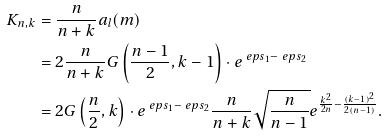<formula> <loc_0><loc_0><loc_500><loc_500>K _ { n , k } & = \frac { n } { n + k } a _ { l } ( m ) \\ & = 2 \frac { n } { n + k } G \left ( \frac { n - 1 } { 2 } , k - 1 \right ) \cdot e ^ { \ e p s _ { 1 } - \ e p s _ { 2 } } \\ & = 2 G \left ( \frac { n } { 2 } , k \right ) \cdot e ^ { \ e p s _ { 1 } - \ e p s _ { 2 } } \frac { n } { n + k } \sqrt { \frac { n } { n - 1 } } e ^ { \frac { k ^ { 2 } } { 2 n } - \frac { ( k - 1 ) ^ { 2 } } { 2 ( n - 1 ) } } .</formula> 